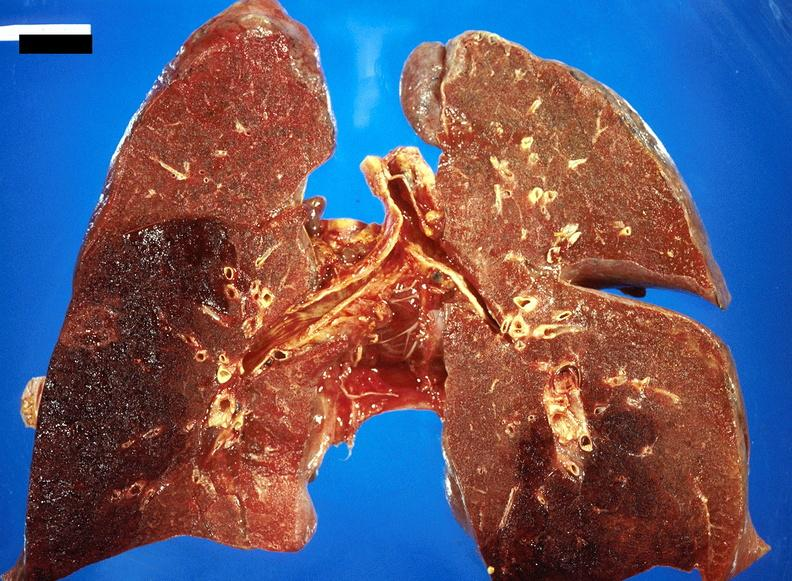what does this image show?
Answer the question using a single word or phrase. Subacute pulmonary thromboembolus with acute infarct 